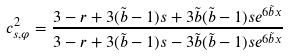Convert formula to latex. <formula><loc_0><loc_0><loc_500><loc_500>c _ { s , \varphi } ^ { 2 } = \frac { 3 - r + 3 ( \tilde { b } - 1 ) s + 3 \tilde { b } ( \tilde { b } - 1 ) s e ^ { 6 \tilde { b } x } } { 3 - r + 3 ( \tilde { b } - 1 ) s - 3 \tilde { b } ( \tilde { b } - 1 ) s e ^ { 6 \tilde { b } x } }</formula> 